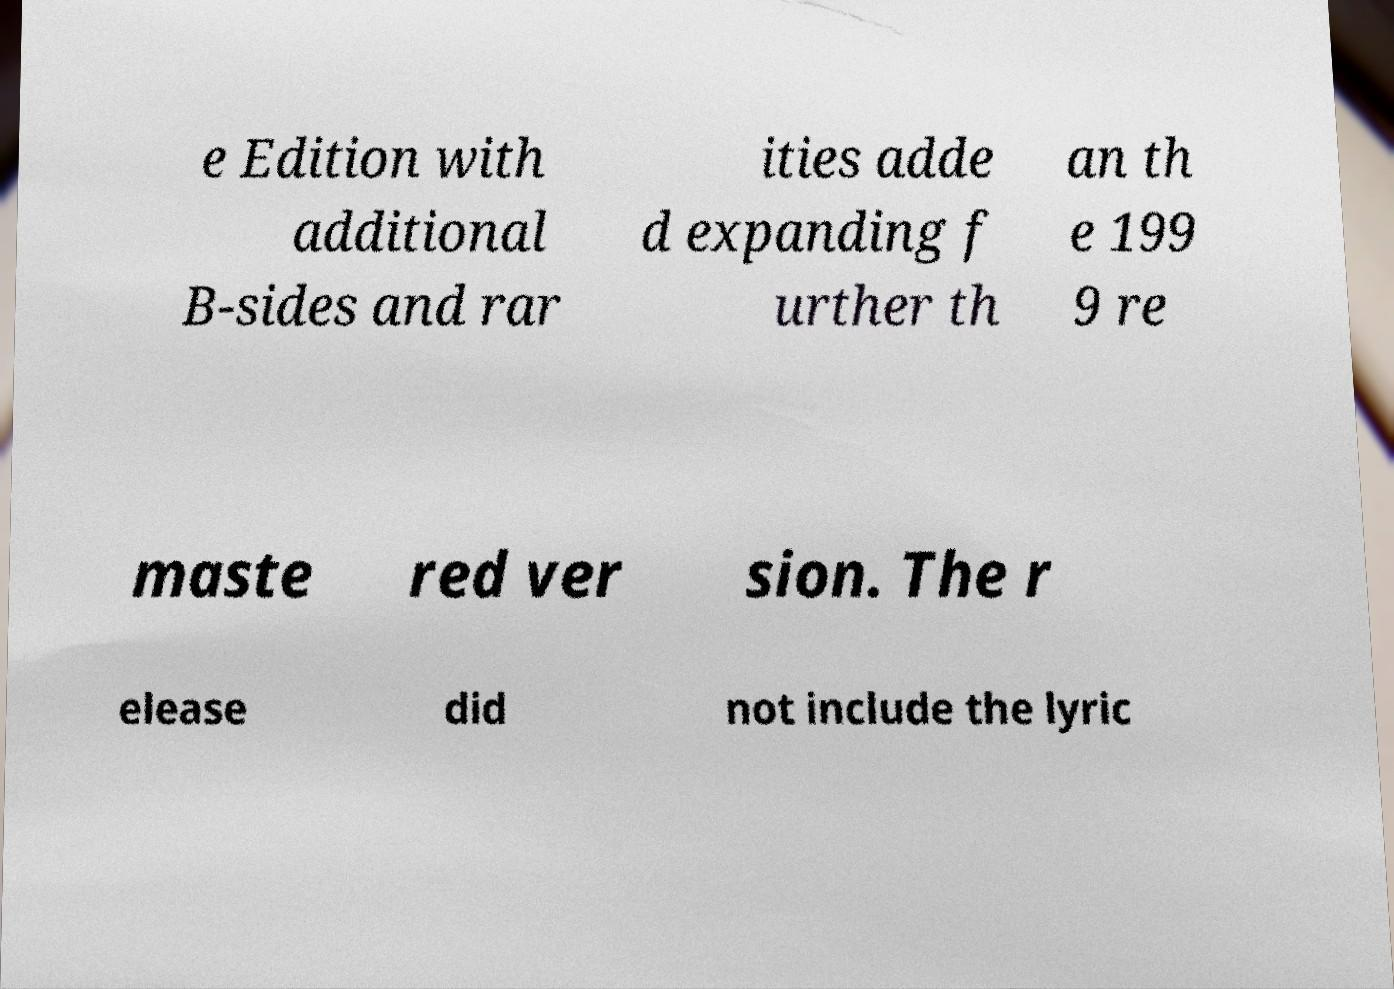Could you assist in decoding the text presented in this image and type it out clearly? e Edition with additional B-sides and rar ities adde d expanding f urther th an th e 199 9 re maste red ver sion. The r elease did not include the lyric 